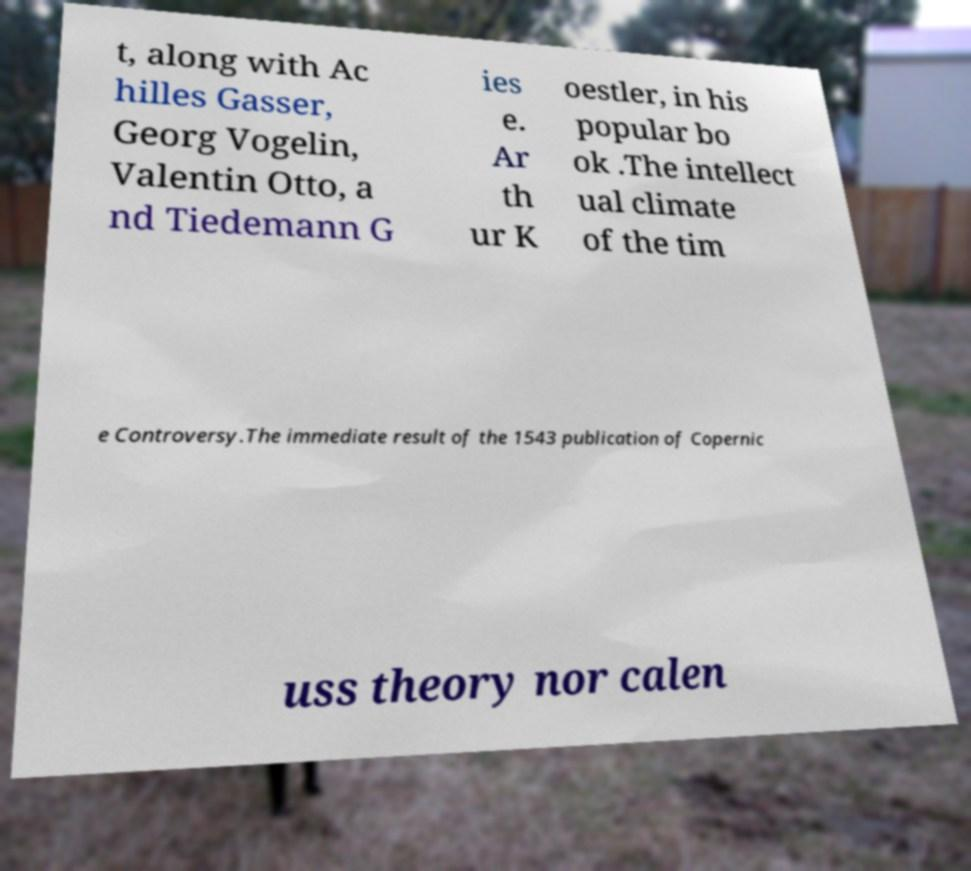Please identify and transcribe the text found in this image. t, along with Ac hilles Gasser, Georg Vogelin, Valentin Otto, a nd Tiedemann G ies e. Ar th ur K oestler, in his popular bo ok .The intellect ual climate of the tim e Controversy.The immediate result of the 1543 publication of Copernic uss theory nor calen 